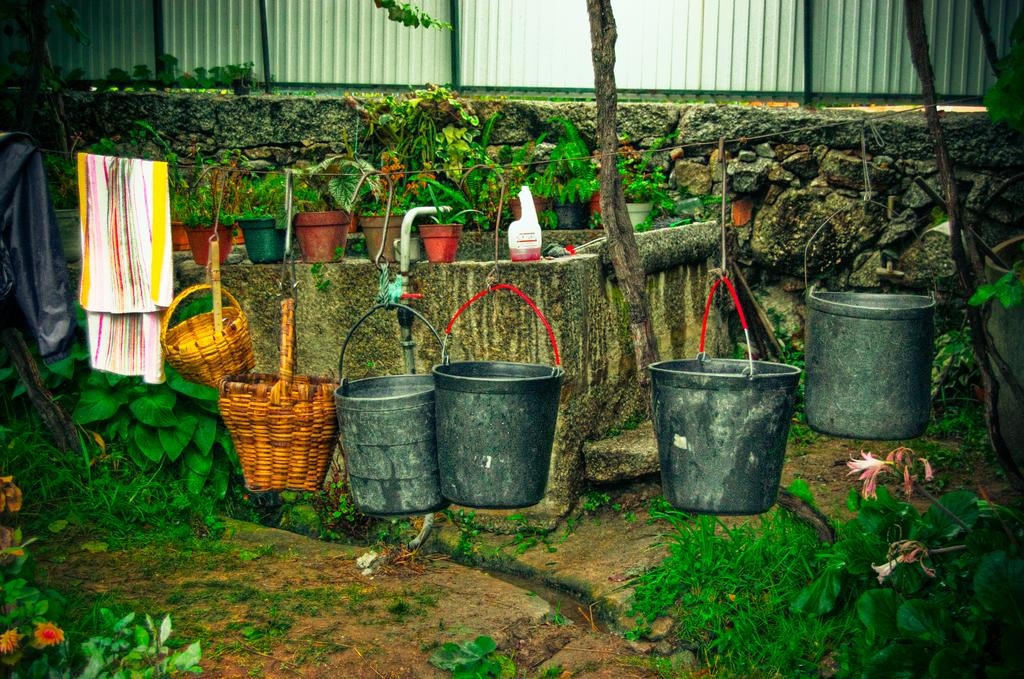What is hanging on the rope in the image? There are clothes, 2 baskets, and 4 buckets hanging on the rope in the image. What can be seen in the background of the image? There are house plants, a bottle, plants, flowers, trees, a wall, and a fence in the background. What reason does the plane have for flying so low in the image? There is no plane present in the image, so it is not possible to determine a reason for flying low. 